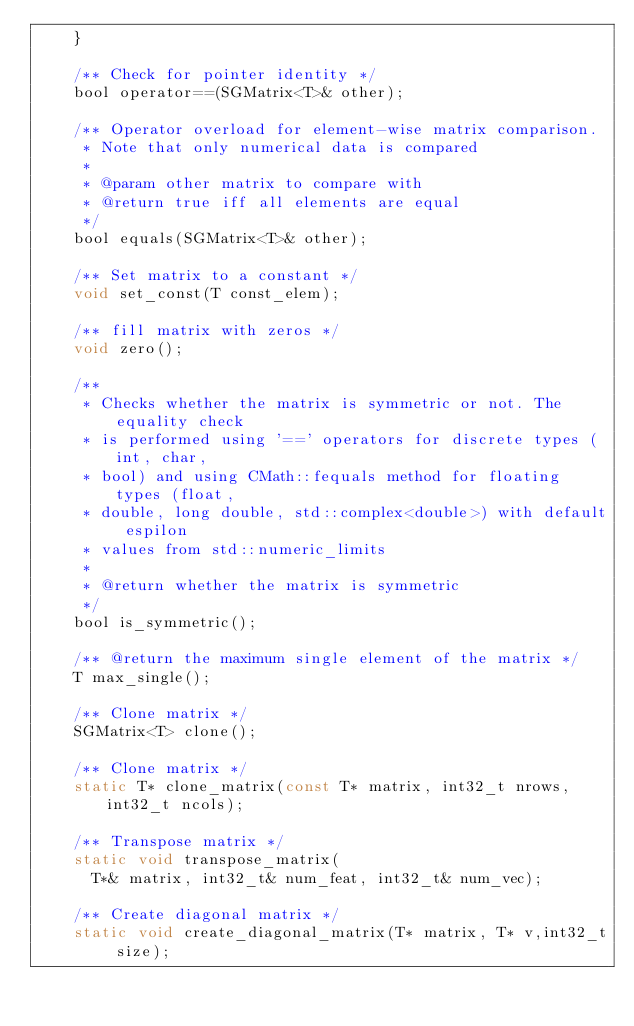<code> <loc_0><loc_0><loc_500><loc_500><_C_>		}

		/** Check for pointer identity */
		bool operator==(SGMatrix<T>& other);

		/** Operator overload for element-wise matrix comparison.
		 * Note that only numerical data is compared
		 *
		 * @param other matrix to compare with
		 * @return true iff all elements are equal
		 */
		bool equals(SGMatrix<T>& other);

		/** Set matrix to a constant */
		void set_const(T const_elem);

		/** fill matrix with zeros */
		void zero();

		/**
		 * Checks whether the matrix is symmetric or not. The equality check
		 * is performed using '==' operators for discrete types (int, char,
		 * bool) and using CMath::fequals method for floating types (float,
		 * double, long double, std::complex<double>) with default espilon
		 * values from std::numeric_limits
		 *
		 * @return whether the matrix is symmetric
		 */
		bool is_symmetric();

		/** @return the maximum single element of the matrix */
		T max_single();

		/** Clone matrix */
		SGMatrix<T> clone();

		/** Clone matrix */
		static T* clone_matrix(const T* matrix, int32_t nrows, int32_t ncols);

		/** Transpose matrix */
		static void transpose_matrix(
			T*& matrix, int32_t& num_feat, int32_t& num_vec);

		/** Create diagonal matrix */
		static void create_diagonal_matrix(T* matrix, T* v,int32_t size);
</code> 